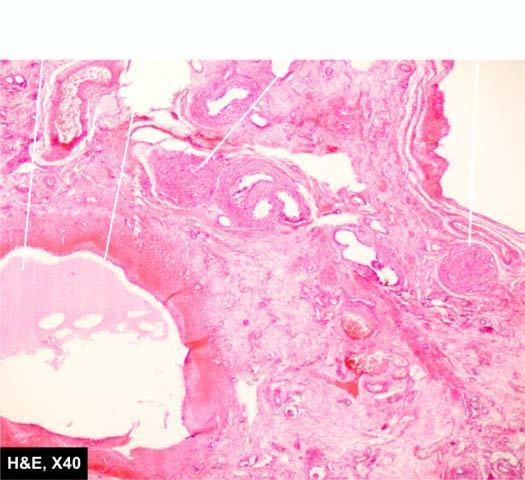does the deposition consist of primitive connective tissue and cartilage?
Answer the question using a single word or phrase. No 